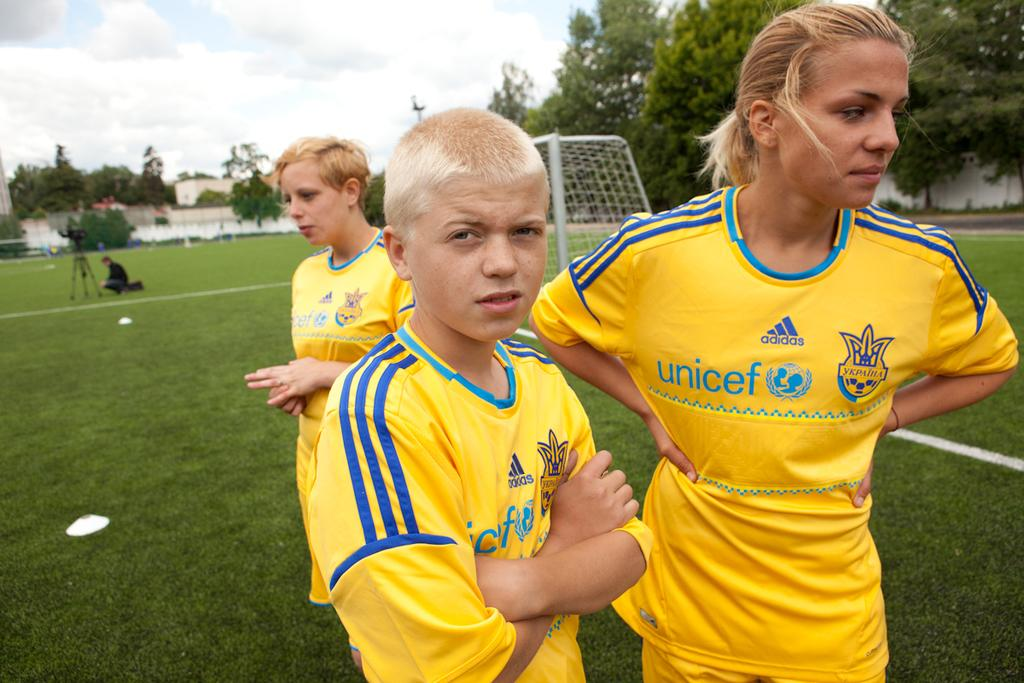Provide a one-sentence caption for the provided image. a jersey with the word Unicef on it. 